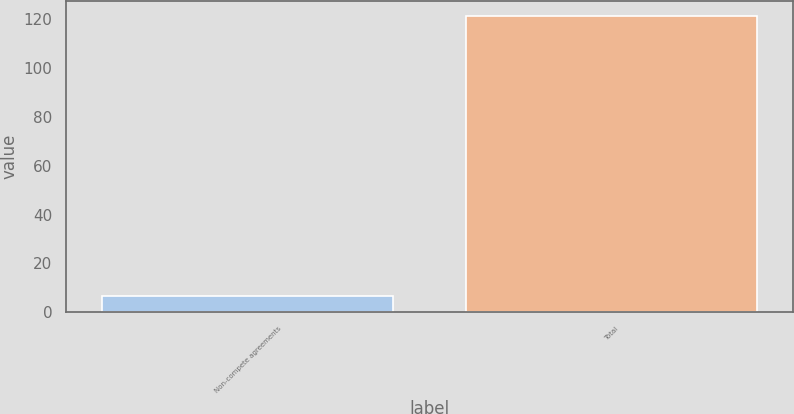Convert chart. <chart><loc_0><loc_0><loc_500><loc_500><bar_chart><fcel>Non-compete agreements<fcel>Total<nl><fcel>6.5<fcel>121.4<nl></chart> 